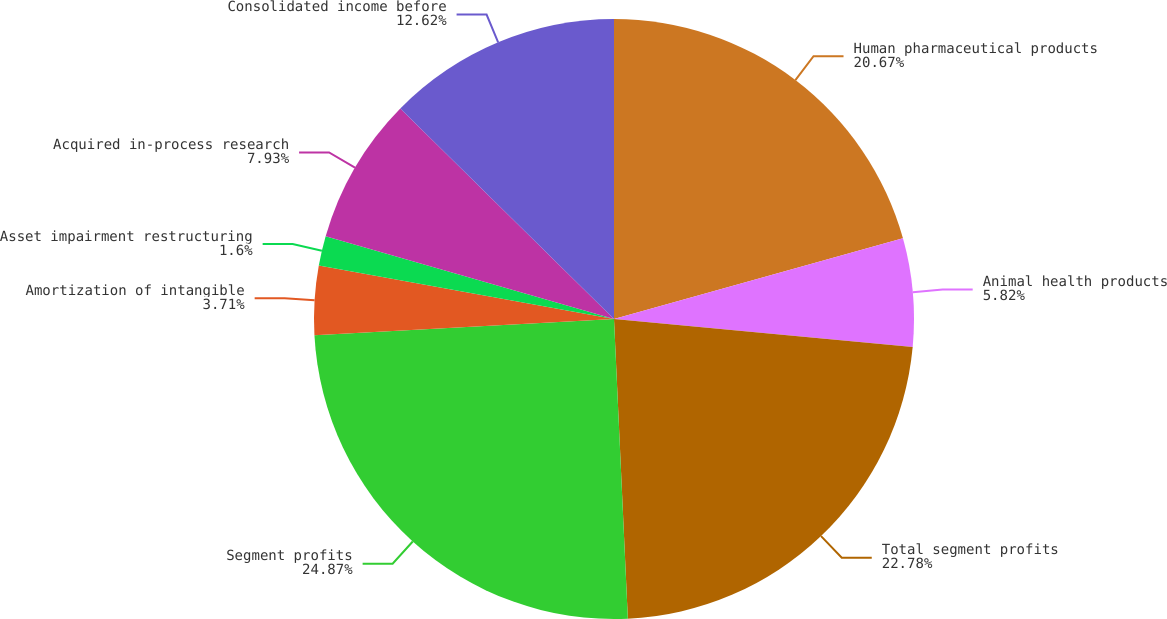Convert chart to OTSL. <chart><loc_0><loc_0><loc_500><loc_500><pie_chart><fcel>Human pharmaceutical products<fcel>Animal health products<fcel>Total segment profits<fcel>Segment profits<fcel>Amortization of intangible<fcel>Asset impairment restructuring<fcel>Acquired in-process research<fcel>Consolidated income before<nl><fcel>20.67%<fcel>5.82%<fcel>22.78%<fcel>24.88%<fcel>3.71%<fcel>1.6%<fcel>7.93%<fcel>12.62%<nl></chart> 